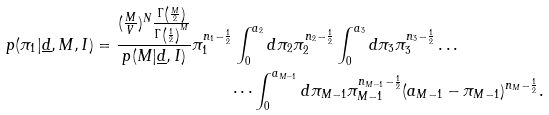Convert formula to latex. <formula><loc_0><loc_0><loc_500><loc_500>p ( \pi _ { 1 } | \underline { d } , M , I ) = \frac { ( \frac { M } { V } ) ^ { N } \frac { \Gamma \left ( \frac { M } { 2 } \right ) } { \Gamma \left ( \frac { 1 } { 2 } \right ) ^ { M } } } { p ( M | \underline { d } , I ) } \pi _ { 1 } ^ { n _ { 1 } - \frac { 1 } { 2 } } & \int ^ { a _ { 2 } } _ { 0 } { d \pi _ { 2 } \pi _ { 2 } ^ { n _ { 2 } - \frac { 1 } { 2 } } } \int ^ { a _ { 3 } } _ { 0 } { d \pi _ { 3 } \pi _ { 3 } ^ { n _ { 3 } - \frac { 1 } { 2 } } } \dots \\ & \dots \int ^ { a _ { M - 1 } } _ { 0 } { d \pi _ { M - 1 } \pi _ { M - 1 } ^ { n _ { M - 1 } - \frac { 1 } { 2 } } ( a _ { M - 1 } - \pi _ { M - 1 } ) ^ { n _ { M } - \frac { 1 } { 2 } } } .</formula> 